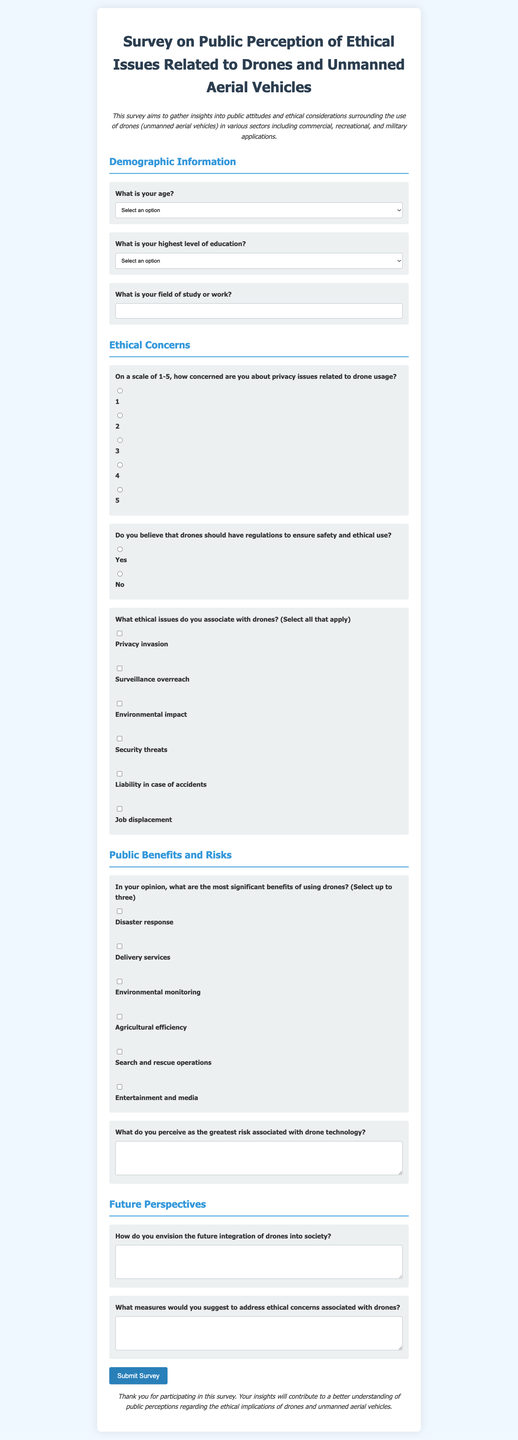What is the title of the survey? The title of the survey is presented prominently at the top of the document, indicating the focus on public perception of ethical issues related to drones and unmanned aerial vehicles.
Answer: Survey on Public Perception of Ethical Issues Related to Drones and Unmanned Aerial Vehicles What is required information for demographic data? The survey specifies two required pieces of demographic information: age and highest level of education, as indicated in the form structure.
Answer: Age and education What scale is used to measure concern about privacy issues? The survey uses a scale from 1 to 5 to gauge concerns about privacy issues, as shown in the relevant section of the document.
Answer: 1-5 What option indicates support for drone regulations? The response option that indicates support for regulations regarding drones is labeled "Yes," allowing respondents to express their agreement.
Answer: Yes What ethical issue is related to job displacement? Job displacement is mentioned as one of the ethical issues associated with drones in the checkbox selections for respondents to identify their concerns.
Answer: Job displacement How many benefits can respondents select regarding drone usage? The survey allows respondents to select up to three benefits of using drones, as specified in the instructions of that section.
Answer: Three What is one suggestion the survey asks participants to provide? The survey invites participants to suggest measures to address the ethical concerns associated with drones, as indicated in the relevant question.
Answer: Measures to address ethical concerns What section follows the "Ethical Concerns" section in the survey? The section that follows "Ethical Concerns" is titled "Public Benefits and Risks," organizing the survey into a clear thematic flow.
Answer: Public Benefits and Risks What is the function of the submit button in the form? The submit button in the form serves to finalize and send the survey responses once completed by the participant.
Answer: Submit survey 